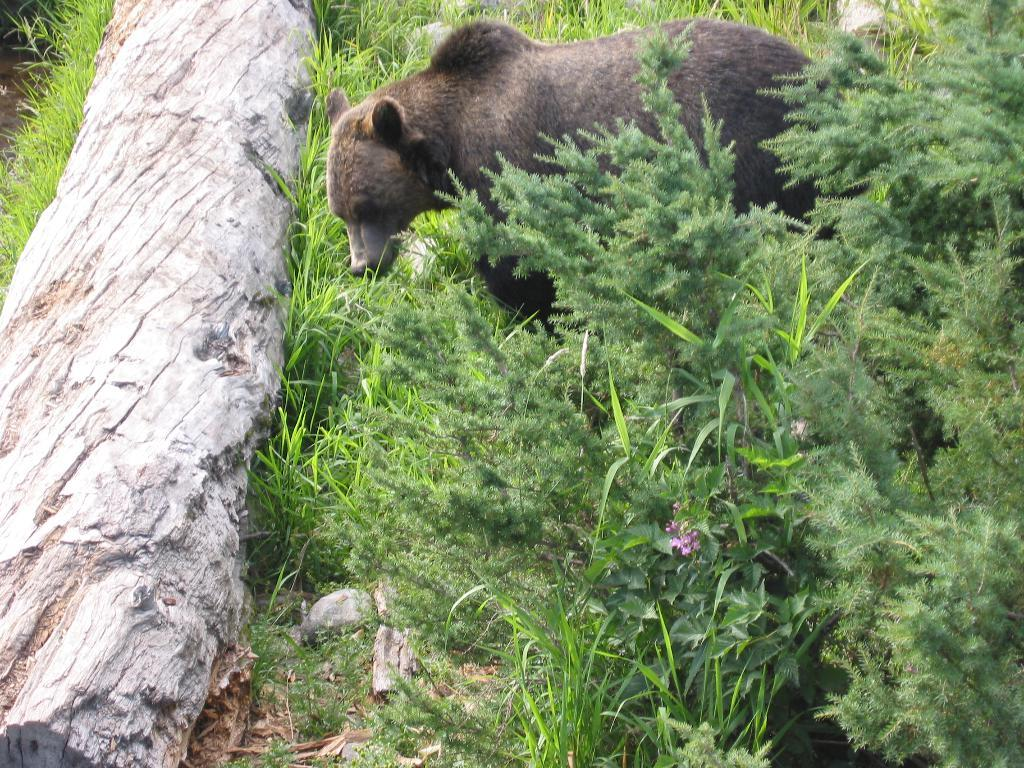What type of animal can be seen in the image? There is an animal in the image, but its specific type cannot be determined from the provided facts. What colors are present on the animal in the image? The animal is brown and black in color. What is the large object in the image made of? There is a huge wooden log in the image. What type of vegetation surrounds the animal? There are trees around the animal. What color are the flowers in the image? There are pink flowers in the image. What reward does the group of animals receive after completing the task in the image? There is no group of animals or task completion mentioned in the image, so it is not possible to determine if a reward is given. 